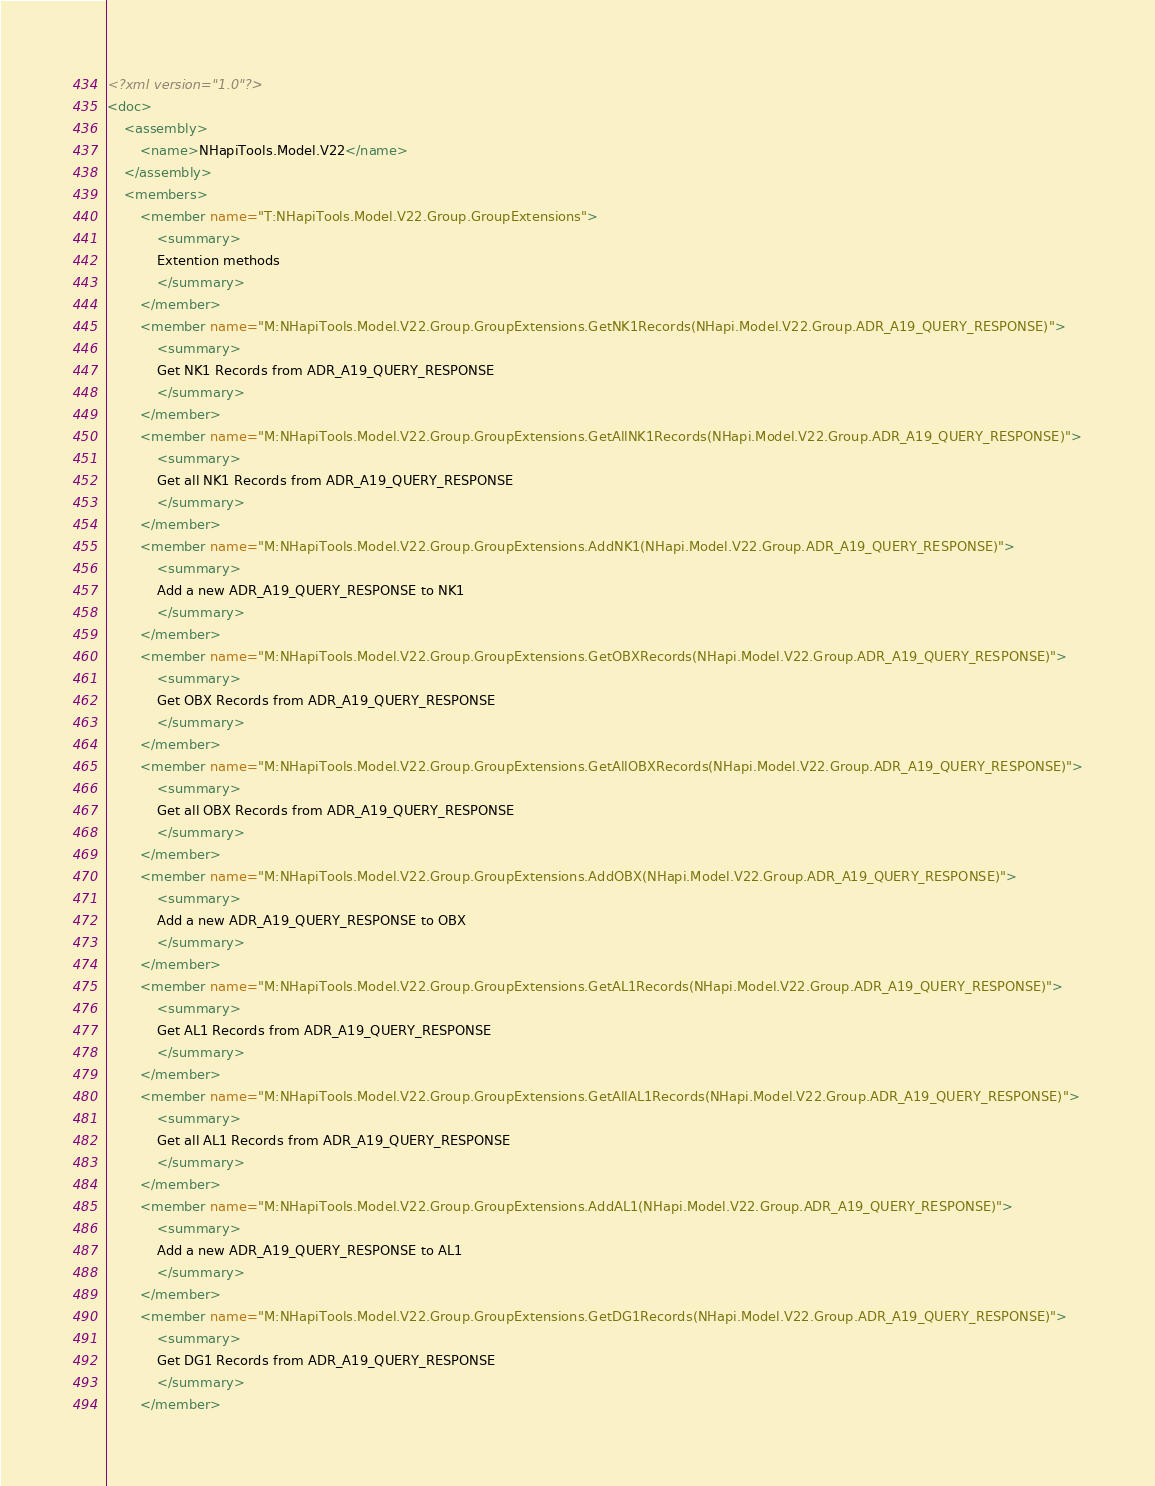<code> <loc_0><loc_0><loc_500><loc_500><_XML_><?xml version="1.0"?>
<doc>
    <assembly>
        <name>NHapiTools.Model.V22</name>
    </assembly>
    <members>
        <member name="T:NHapiTools.Model.V22.Group.GroupExtensions">
            <summary>
            Extention methods
            </summary>
        </member>
        <member name="M:NHapiTools.Model.V22.Group.GroupExtensions.GetNK1Records(NHapi.Model.V22.Group.ADR_A19_QUERY_RESPONSE)">
            <summary>
            Get NK1 Records from ADR_A19_QUERY_RESPONSE
            </summary>
        </member>
        <member name="M:NHapiTools.Model.V22.Group.GroupExtensions.GetAllNK1Records(NHapi.Model.V22.Group.ADR_A19_QUERY_RESPONSE)">
            <summary>
            Get all NK1 Records from ADR_A19_QUERY_RESPONSE
            </summary>
        </member>
        <member name="M:NHapiTools.Model.V22.Group.GroupExtensions.AddNK1(NHapi.Model.V22.Group.ADR_A19_QUERY_RESPONSE)">
            <summary>
            Add a new ADR_A19_QUERY_RESPONSE to NK1
            </summary>
        </member>
        <member name="M:NHapiTools.Model.V22.Group.GroupExtensions.GetOBXRecords(NHapi.Model.V22.Group.ADR_A19_QUERY_RESPONSE)">
            <summary>
            Get OBX Records from ADR_A19_QUERY_RESPONSE
            </summary>
        </member>
        <member name="M:NHapiTools.Model.V22.Group.GroupExtensions.GetAllOBXRecords(NHapi.Model.V22.Group.ADR_A19_QUERY_RESPONSE)">
            <summary>
            Get all OBX Records from ADR_A19_QUERY_RESPONSE
            </summary>
        </member>
        <member name="M:NHapiTools.Model.V22.Group.GroupExtensions.AddOBX(NHapi.Model.V22.Group.ADR_A19_QUERY_RESPONSE)">
            <summary>
            Add a new ADR_A19_QUERY_RESPONSE to OBX
            </summary>
        </member>
        <member name="M:NHapiTools.Model.V22.Group.GroupExtensions.GetAL1Records(NHapi.Model.V22.Group.ADR_A19_QUERY_RESPONSE)">
            <summary>
            Get AL1 Records from ADR_A19_QUERY_RESPONSE
            </summary>
        </member>
        <member name="M:NHapiTools.Model.V22.Group.GroupExtensions.GetAllAL1Records(NHapi.Model.V22.Group.ADR_A19_QUERY_RESPONSE)">
            <summary>
            Get all AL1 Records from ADR_A19_QUERY_RESPONSE
            </summary>
        </member>
        <member name="M:NHapiTools.Model.V22.Group.GroupExtensions.AddAL1(NHapi.Model.V22.Group.ADR_A19_QUERY_RESPONSE)">
            <summary>
            Add a new ADR_A19_QUERY_RESPONSE to AL1
            </summary>
        </member>
        <member name="M:NHapiTools.Model.V22.Group.GroupExtensions.GetDG1Records(NHapi.Model.V22.Group.ADR_A19_QUERY_RESPONSE)">
            <summary>
            Get DG1 Records from ADR_A19_QUERY_RESPONSE
            </summary>
        </member></code> 